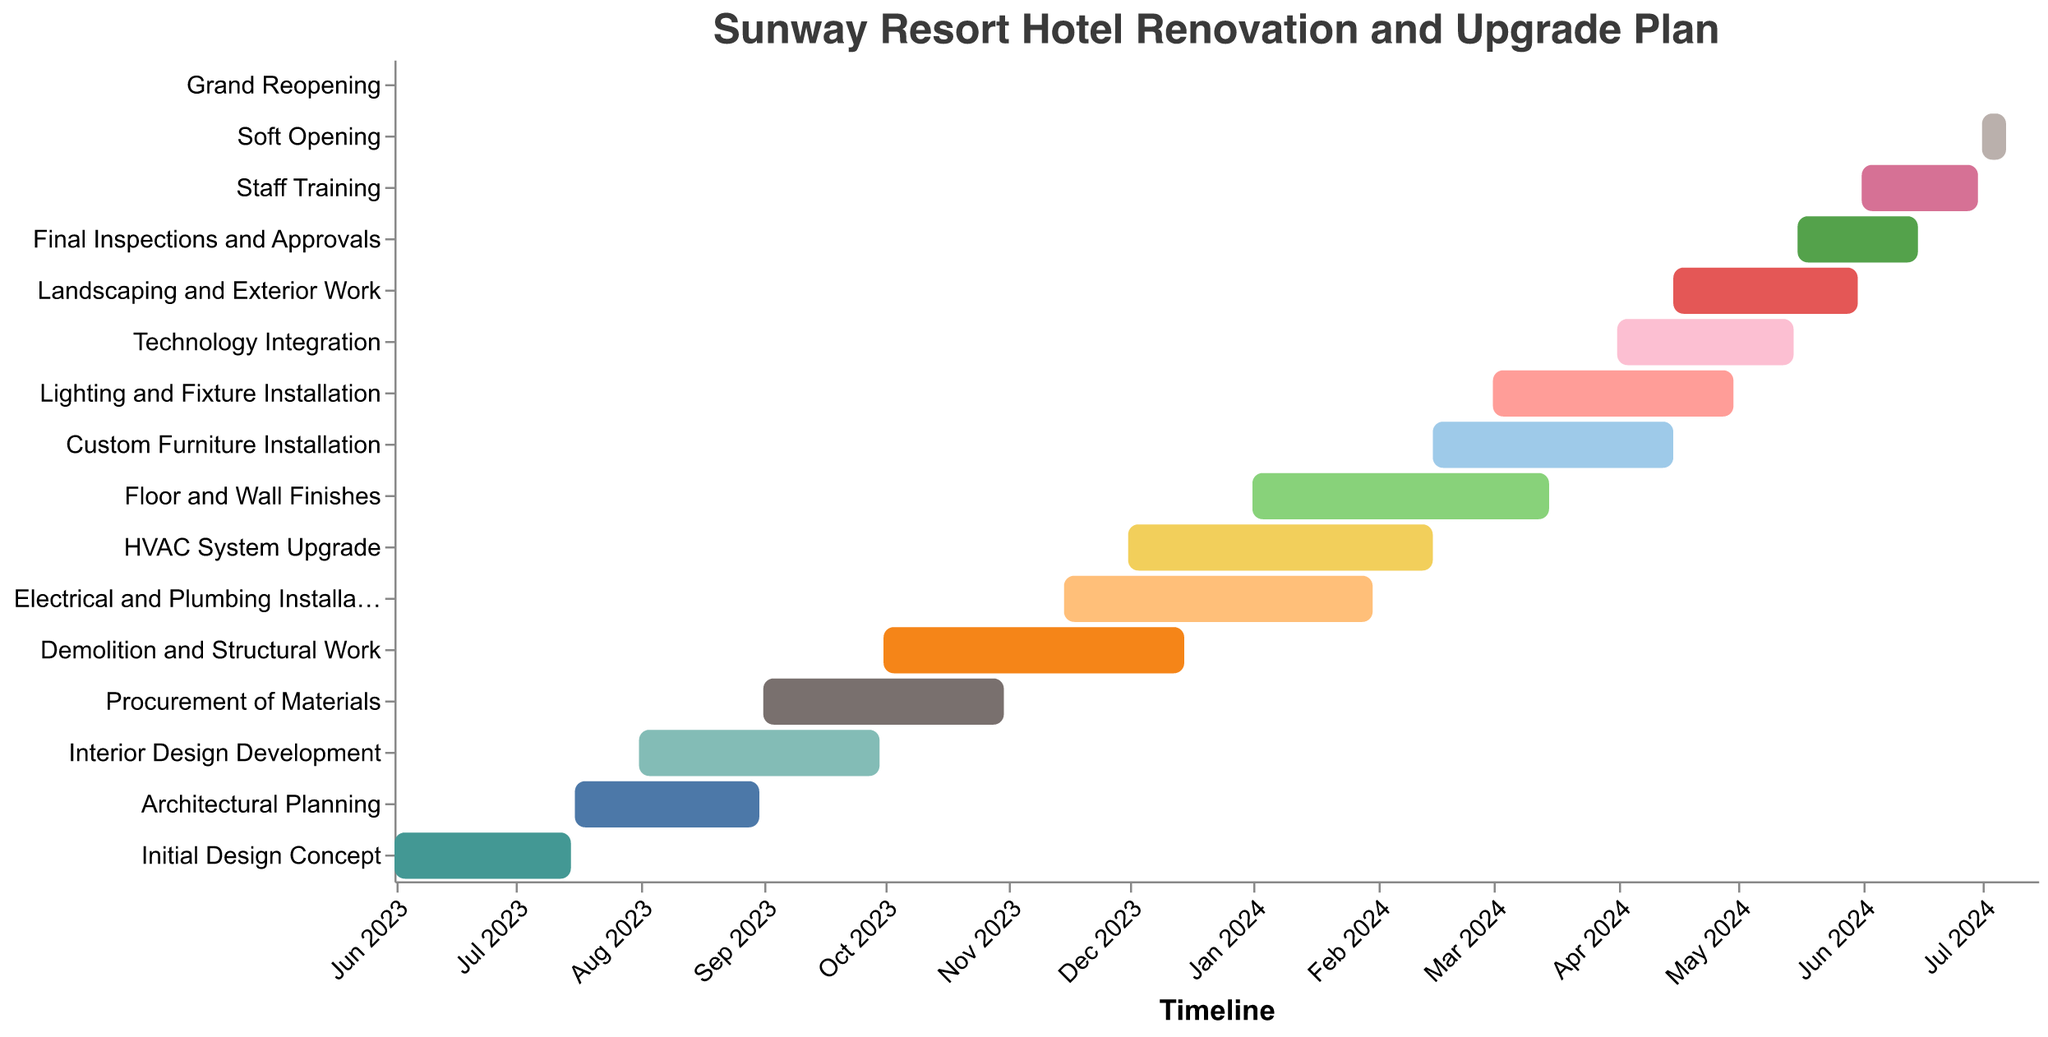How long does the Demolition and Structural Work phase last? According to the Gantt chart, the Demolition and Structural Work phase starts on October 1, 2023, and ends on December 15, 2023, which gives a total duration of 76 days.
Answer: 76 days Which task has the shortest duration in the project? By observing the duration of all tasks, the Grand Reopening phase has the shortest duration, lasting only 1 day.
Answer: Grand Reopening What tasks overlap with the Electrical and Plumbing Installation phase? The Electrical and Plumbing Installation phase overlaps with the Demolition and Structural Work, HVAC System Upgrade, and Floor and Wall Finishes tasks.
Answer: Demolition and Structural Work, HVAC System Upgrade, Floor and Wall Finishes When does the Interior Design Development phase start and end? The Interior Design Development phase starts on August 1, 2023, and ends on September 30, 2023, according to the Gantt chart.
Answer: August 1, 2023, to September 30, 2023 Which phase starts right after the HVAC System Upgrade? Based on the Gantt chart, the Custom Furniture Installation phase begins immediately after the HVAC System Upgrade ends on February 15, 2024.
Answer: Custom Furniture Installation Which tasks have a duration of over 70 days? By checking the duration, the tasks with over 70 days are Demolition and Structural Work (76 days), Electrical and Plumbing Installation (78 days), HVAC System Upgrade (77 days), and Floor and Wall Finishes (75 days).
Answer: Demolition and Structural Work, Electrical and Plumbing Installation, HVAC System Upgrade, Floor and Wall Finishes When is the Final Inspections and Approvals phase scheduled to occur? According to the Gantt chart, the Final Inspections and Approvals phase is scheduled from May 16, 2024, to June 15, 2024.
Answer: May 16, 2024, to June 15, 2024 How much time is scheduled between the Soft Opening and the Grand Reopening? The Soft Opening ends on July 7, 2024, and the Grand Reopening is on July 15, 2024, leaving an interval of 8 days between them.
Answer: 8 days What are the first and last tasks in the renovation schedule? The first task is the Initial Design Concept starting on June 1, 2023, and the last task is the Grand Reopening on July 15, 2024.
Answer: Initial Design Concept and Grand Reopening 